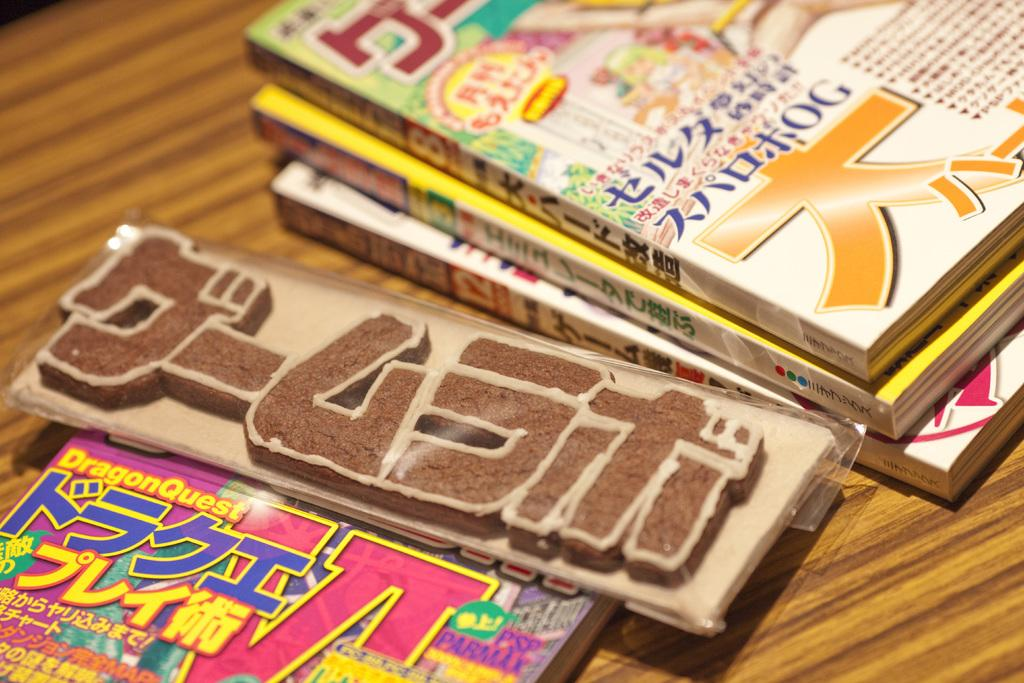Provide a one-sentence caption for the provided image. Three Japanese books sitting on top of each other on a table, and a small nameplate beside the books. 